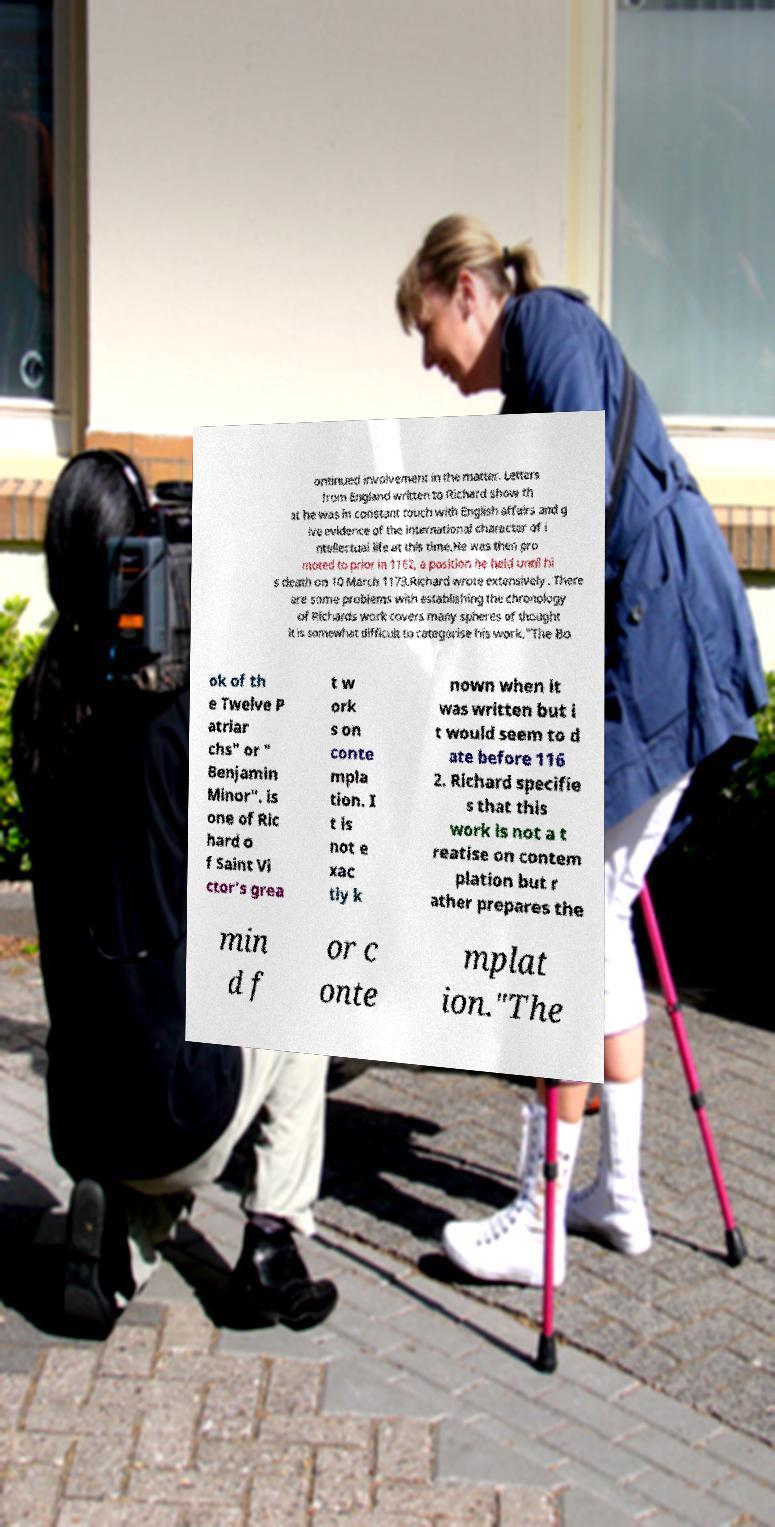Can you read and provide the text displayed in the image?This photo seems to have some interesting text. Can you extract and type it out for me? ontinued involvement in the matter. Letters from England written to Richard show th at he was in constant touch with English affairs and g ive evidence of the international character of i ntellectual life at this time.He was then pro moted to prior in 1162, a position he held until hi s death on 10 March 1173.Richard wrote extensively . There are some problems with establishing the chronology of Richards work covers many spheres of thought it is somewhat difficult to categorise his work."The Bo ok of th e Twelve P atriar chs" or " Benjamin Minor". is one of Ric hard o f Saint Vi ctor's grea t w ork s on conte mpla tion. I t is not e xac tly k nown when it was written but i t would seem to d ate before 116 2. Richard specifie s that this work is not a t reatise on contem plation but r ather prepares the min d f or c onte mplat ion."The 